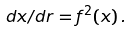<formula> <loc_0><loc_0><loc_500><loc_500>d x / d r = f ^ { 2 } ( x ) \, .</formula> 